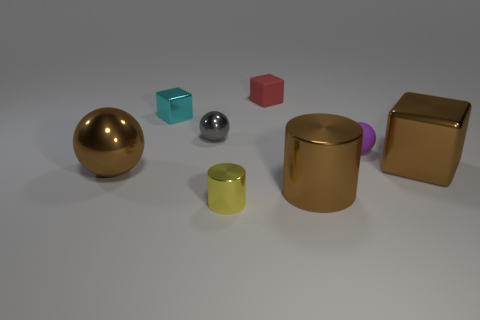There is a metallic cylinder that is left of the red cube; is its size the same as the metallic block that is left of the small shiny cylinder? Although there are similarities, the sizes of the metallic cylinder on the left of the red cube and the metallic block on the left of the small shiny cylinder are not identical. The metallic block appears larger with a more substantial volume, while the cylinder has a narrower diameter and height. 